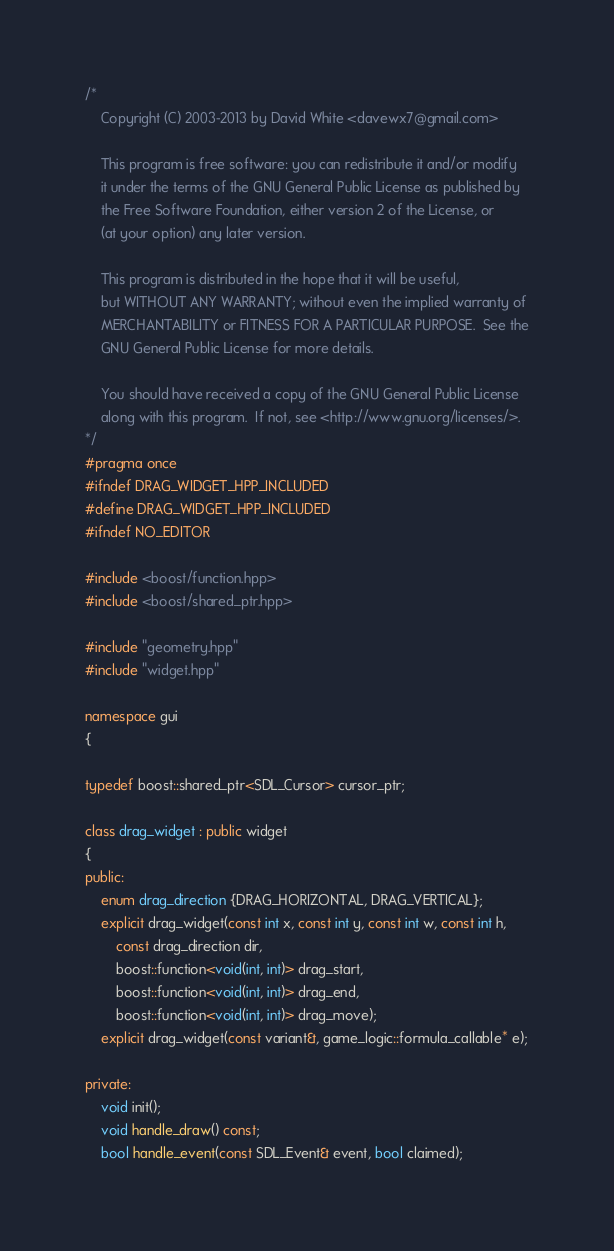Convert code to text. <code><loc_0><loc_0><loc_500><loc_500><_C++_>/*
	Copyright (C) 2003-2013 by David White <davewx7@gmail.com>
	
    This program is free software: you can redistribute it and/or modify
    it under the terms of the GNU General Public License as published by
    the Free Software Foundation, either version 2 of the License, or
    (at your option) any later version.

    This program is distributed in the hope that it will be useful,
    but WITHOUT ANY WARRANTY; without even the implied warranty of
    MERCHANTABILITY or FITNESS FOR A PARTICULAR PURPOSE.  See the
    GNU General Public License for more details.

    You should have received a copy of the GNU General Public License
    along with this program.  If not, see <http://www.gnu.org/licenses/>.
*/
#pragma once
#ifndef DRAG_WIDGET_HPP_INCLUDED
#define DRAG_WIDGET_HPP_INCLUDED
#ifndef NO_EDITOR

#include <boost/function.hpp>
#include <boost/shared_ptr.hpp>

#include "geometry.hpp"
#include "widget.hpp"

namespace gui
{

typedef boost::shared_ptr<SDL_Cursor> cursor_ptr;

class drag_widget : public widget
{
public:
	enum drag_direction {DRAG_HORIZONTAL, DRAG_VERTICAL};
	explicit drag_widget(const int x, const int y, const int w, const int h,
		const drag_direction dir,
		boost::function<void(int, int)> drag_start, 
		boost::function<void(int, int)> drag_end, 
		boost::function<void(int, int)> drag_move);
	explicit drag_widget(const variant&, game_logic::formula_callable* e);

private:
	void init();
	void handle_draw() const;
	bool handle_event(const SDL_Event& event, bool claimed);</code> 